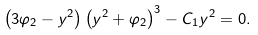<formula> <loc_0><loc_0><loc_500><loc_500>\left ( 3 \varphi _ { 2 } - y ^ { 2 } \right ) \left ( y ^ { 2 } + \varphi _ { 2 } \right ) ^ { 3 } - C _ { 1 } y ^ { 2 } = 0 .</formula> 